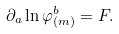Convert formula to latex. <formula><loc_0><loc_0><loc_500><loc_500>\partial _ { a } \ln \varphi _ { ( m ) } ^ { b } = F .</formula> 